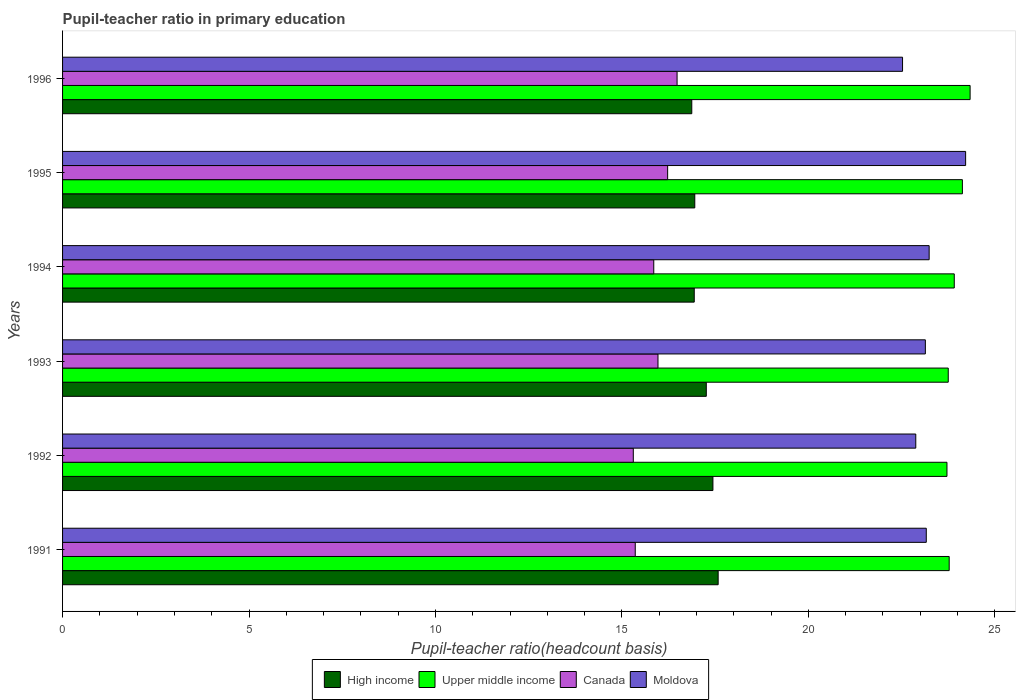How many different coloured bars are there?
Offer a terse response. 4. How many groups of bars are there?
Give a very brief answer. 6. Are the number of bars per tick equal to the number of legend labels?
Your answer should be very brief. Yes. How many bars are there on the 5th tick from the top?
Provide a short and direct response. 4. What is the label of the 1st group of bars from the top?
Your answer should be compact. 1996. In how many cases, is the number of bars for a given year not equal to the number of legend labels?
Your response must be concise. 0. What is the pupil-teacher ratio in primary education in High income in 1991?
Your answer should be very brief. 17.58. Across all years, what is the maximum pupil-teacher ratio in primary education in Moldova?
Your answer should be compact. 24.22. Across all years, what is the minimum pupil-teacher ratio in primary education in High income?
Your answer should be very brief. 16.87. What is the total pupil-teacher ratio in primary education in High income in the graph?
Offer a terse response. 103.05. What is the difference between the pupil-teacher ratio in primary education in Canada in 1995 and that in 1996?
Give a very brief answer. -0.25. What is the difference between the pupil-teacher ratio in primary education in Canada in 1992 and the pupil-teacher ratio in primary education in High income in 1996?
Keep it short and to the point. -1.57. What is the average pupil-teacher ratio in primary education in High income per year?
Offer a terse response. 17.17. In the year 1991, what is the difference between the pupil-teacher ratio in primary education in High income and pupil-teacher ratio in primary education in Canada?
Provide a short and direct response. 2.22. What is the ratio of the pupil-teacher ratio in primary education in High income in 1992 to that in 1994?
Offer a very short reply. 1.03. What is the difference between the highest and the second highest pupil-teacher ratio in primary education in Canada?
Offer a very short reply. 0.25. What is the difference between the highest and the lowest pupil-teacher ratio in primary education in Canada?
Ensure brevity in your answer.  1.17. In how many years, is the pupil-teacher ratio in primary education in High income greater than the average pupil-teacher ratio in primary education in High income taken over all years?
Make the answer very short. 3. What does the 3rd bar from the top in 1992 represents?
Ensure brevity in your answer.  Upper middle income. Is it the case that in every year, the sum of the pupil-teacher ratio in primary education in Upper middle income and pupil-teacher ratio in primary education in Moldova is greater than the pupil-teacher ratio in primary education in High income?
Provide a succinct answer. Yes. Does the graph contain any zero values?
Ensure brevity in your answer.  No. Does the graph contain grids?
Offer a terse response. No. Where does the legend appear in the graph?
Your answer should be very brief. Bottom center. How many legend labels are there?
Provide a succinct answer. 4. What is the title of the graph?
Offer a terse response. Pupil-teacher ratio in primary education. Does "Dominican Republic" appear as one of the legend labels in the graph?
Ensure brevity in your answer.  No. What is the label or title of the X-axis?
Offer a very short reply. Pupil-teacher ratio(headcount basis). What is the label or title of the Y-axis?
Your answer should be very brief. Years. What is the Pupil-teacher ratio(headcount basis) in High income in 1991?
Offer a very short reply. 17.58. What is the Pupil-teacher ratio(headcount basis) in Upper middle income in 1991?
Ensure brevity in your answer.  23.78. What is the Pupil-teacher ratio(headcount basis) in Canada in 1991?
Provide a succinct answer. 15.36. What is the Pupil-teacher ratio(headcount basis) in Moldova in 1991?
Offer a very short reply. 23.16. What is the Pupil-teacher ratio(headcount basis) of High income in 1992?
Ensure brevity in your answer.  17.44. What is the Pupil-teacher ratio(headcount basis) of Upper middle income in 1992?
Provide a short and direct response. 23.72. What is the Pupil-teacher ratio(headcount basis) in Canada in 1992?
Provide a short and direct response. 15.3. What is the Pupil-teacher ratio(headcount basis) in Moldova in 1992?
Offer a very short reply. 22.88. What is the Pupil-teacher ratio(headcount basis) of High income in 1993?
Your response must be concise. 17.26. What is the Pupil-teacher ratio(headcount basis) in Upper middle income in 1993?
Keep it short and to the point. 23.75. What is the Pupil-teacher ratio(headcount basis) in Canada in 1993?
Your answer should be compact. 15.97. What is the Pupil-teacher ratio(headcount basis) in Moldova in 1993?
Offer a very short reply. 23.14. What is the Pupil-teacher ratio(headcount basis) in High income in 1994?
Your answer should be very brief. 16.94. What is the Pupil-teacher ratio(headcount basis) in Upper middle income in 1994?
Provide a short and direct response. 23.91. What is the Pupil-teacher ratio(headcount basis) of Canada in 1994?
Ensure brevity in your answer.  15.85. What is the Pupil-teacher ratio(headcount basis) of Moldova in 1994?
Provide a short and direct response. 23.24. What is the Pupil-teacher ratio(headcount basis) of High income in 1995?
Offer a terse response. 16.95. What is the Pupil-teacher ratio(headcount basis) in Upper middle income in 1995?
Your response must be concise. 24.13. What is the Pupil-teacher ratio(headcount basis) of Canada in 1995?
Offer a very short reply. 16.23. What is the Pupil-teacher ratio(headcount basis) in Moldova in 1995?
Your response must be concise. 24.22. What is the Pupil-teacher ratio(headcount basis) in High income in 1996?
Provide a succinct answer. 16.87. What is the Pupil-teacher ratio(headcount basis) in Upper middle income in 1996?
Provide a succinct answer. 24.34. What is the Pupil-teacher ratio(headcount basis) of Canada in 1996?
Give a very brief answer. 16.48. What is the Pupil-teacher ratio(headcount basis) of Moldova in 1996?
Your answer should be very brief. 22.52. Across all years, what is the maximum Pupil-teacher ratio(headcount basis) of High income?
Provide a short and direct response. 17.58. Across all years, what is the maximum Pupil-teacher ratio(headcount basis) of Upper middle income?
Offer a terse response. 24.34. Across all years, what is the maximum Pupil-teacher ratio(headcount basis) of Canada?
Offer a terse response. 16.48. Across all years, what is the maximum Pupil-teacher ratio(headcount basis) in Moldova?
Give a very brief answer. 24.22. Across all years, what is the minimum Pupil-teacher ratio(headcount basis) of High income?
Your response must be concise. 16.87. Across all years, what is the minimum Pupil-teacher ratio(headcount basis) in Upper middle income?
Keep it short and to the point. 23.72. Across all years, what is the minimum Pupil-teacher ratio(headcount basis) of Canada?
Keep it short and to the point. 15.3. Across all years, what is the minimum Pupil-teacher ratio(headcount basis) in Moldova?
Make the answer very short. 22.52. What is the total Pupil-teacher ratio(headcount basis) in High income in the graph?
Your answer should be very brief. 103.05. What is the total Pupil-teacher ratio(headcount basis) of Upper middle income in the graph?
Make the answer very short. 143.62. What is the total Pupil-teacher ratio(headcount basis) in Canada in the graph?
Offer a terse response. 95.19. What is the total Pupil-teacher ratio(headcount basis) in Moldova in the graph?
Keep it short and to the point. 139.16. What is the difference between the Pupil-teacher ratio(headcount basis) of High income in 1991 and that in 1992?
Offer a terse response. 0.14. What is the difference between the Pupil-teacher ratio(headcount basis) in Upper middle income in 1991 and that in 1992?
Make the answer very short. 0.06. What is the difference between the Pupil-teacher ratio(headcount basis) of Canada in 1991 and that in 1992?
Offer a very short reply. 0.05. What is the difference between the Pupil-teacher ratio(headcount basis) in Moldova in 1991 and that in 1992?
Make the answer very short. 0.28. What is the difference between the Pupil-teacher ratio(headcount basis) of High income in 1991 and that in 1993?
Your response must be concise. 0.32. What is the difference between the Pupil-teacher ratio(headcount basis) of Upper middle income in 1991 and that in 1993?
Provide a short and direct response. 0.03. What is the difference between the Pupil-teacher ratio(headcount basis) in Canada in 1991 and that in 1993?
Offer a terse response. -0.61. What is the difference between the Pupil-teacher ratio(headcount basis) of Moldova in 1991 and that in 1993?
Your response must be concise. 0.02. What is the difference between the Pupil-teacher ratio(headcount basis) of High income in 1991 and that in 1994?
Your answer should be compact. 0.64. What is the difference between the Pupil-teacher ratio(headcount basis) of Upper middle income in 1991 and that in 1994?
Provide a succinct answer. -0.14. What is the difference between the Pupil-teacher ratio(headcount basis) of Canada in 1991 and that in 1994?
Give a very brief answer. -0.5. What is the difference between the Pupil-teacher ratio(headcount basis) of Moldova in 1991 and that in 1994?
Offer a terse response. -0.08. What is the difference between the Pupil-teacher ratio(headcount basis) of High income in 1991 and that in 1995?
Offer a very short reply. 0.63. What is the difference between the Pupil-teacher ratio(headcount basis) of Upper middle income in 1991 and that in 1995?
Ensure brevity in your answer.  -0.35. What is the difference between the Pupil-teacher ratio(headcount basis) in Canada in 1991 and that in 1995?
Provide a succinct answer. -0.87. What is the difference between the Pupil-teacher ratio(headcount basis) in Moldova in 1991 and that in 1995?
Offer a very short reply. -1.06. What is the difference between the Pupil-teacher ratio(headcount basis) in High income in 1991 and that in 1996?
Keep it short and to the point. 0.71. What is the difference between the Pupil-teacher ratio(headcount basis) of Upper middle income in 1991 and that in 1996?
Give a very brief answer. -0.56. What is the difference between the Pupil-teacher ratio(headcount basis) of Canada in 1991 and that in 1996?
Offer a very short reply. -1.12. What is the difference between the Pupil-teacher ratio(headcount basis) of Moldova in 1991 and that in 1996?
Give a very brief answer. 0.64. What is the difference between the Pupil-teacher ratio(headcount basis) of High income in 1992 and that in 1993?
Your answer should be compact. 0.18. What is the difference between the Pupil-teacher ratio(headcount basis) in Upper middle income in 1992 and that in 1993?
Provide a succinct answer. -0.03. What is the difference between the Pupil-teacher ratio(headcount basis) in Canada in 1992 and that in 1993?
Your answer should be compact. -0.66. What is the difference between the Pupil-teacher ratio(headcount basis) in Moldova in 1992 and that in 1993?
Your answer should be compact. -0.26. What is the difference between the Pupil-teacher ratio(headcount basis) of High income in 1992 and that in 1994?
Ensure brevity in your answer.  0.5. What is the difference between the Pupil-teacher ratio(headcount basis) of Upper middle income in 1992 and that in 1994?
Provide a short and direct response. -0.2. What is the difference between the Pupil-teacher ratio(headcount basis) of Canada in 1992 and that in 1994?
Ensure brevity in your answer.  -0.55. What is the difference between the Pupil-teacher ratio(headcount basis) of Moldova in 1992 and that in 1994?
Give a very brief answer. -0.36. What is the difference between the Pupil-teacher ratio(headcount basis) of High income in 1992 and that in 1995?
Provide a short and direct response. 0.49. What is the difference between the Pupil-teacher ratio(headcount basis) of Upper middle income in 1992 and that in 1995?
Offer a terse response. -0.41. What is the difference between the Pupil-teacher ratio(headcount basis) in Canada in 1992 and that in 1995?
Provide a short and direct response. -0.92. What is the difference between the Pupil-teacher ratio(headcount basis) of Moldova in 1992 and that in 1995?
Ensure brevity in your answer.  -1.34. What is the difference between the Pupil-teacher ratio(headcount basis) in High income in 1992 and that in 1996?
Your response must be concise. 0.57. What is the difference between the Pupil-teacher ratio(headcount basis) in Upper middle income in 1992 and that in 1996?
Provide a short and direct response. -0.62. What is the difference between the Pupil-teacher ratio(headcount basis) in Canada in 1992 and that in 1996?
Give a very brief answer. -1.17. What is the difference between the Pupil-teacher ratio(headcount basis) of Moldova in 1992 and that in 1996?
Your answer should be compact. 0.35. What is the difference between the Pupil-teacher ratio(headcount basis) of High income in 1993 and that in 1994?
Your answer should be very brief. 0.32. What is the difference between the Pupil-teacher ratio(headcount basis) in Upper middle income in 1993 and that in 1994?
Provide a succinct answer. -0.16. What is the difference between the Pupil-teacher ratio(headcount basis) in Canada in 1993 and that in 1994?
Provide a short and direct response. 0.11. What is the difference between the Pupil-teacher ratio(headcount basis) in Moldova in 1993 and that in 1994?
Your answer should be compact. -0.1. What is the difference between the Pupil-teacher ratio(headcount basis) of High income in 1993 and that in 1995?
Make the answer very short. 0.31. What is the difference between the Pupil-teacher ratio(headcount basis) in Upper middle income in 1993 and that in 1995?
Make the answer very short. -0.38. What is the difference between the Pupil-teacher ratio(headcount basis) in Canada in 1993 and that in 1995?
Keep it short and to the point. -0.26. What is the difference between the Pupil-teacher ratio(headcount basis) of Moldova in 1993 and that in 1995?
Provide a succinct answer. -1.08. What is the difference between the Pupil-teacher ratio(headcount basis) in High income in 1993 and that in 1996?
Offer a very short reply. 0.39. What is the difference between the Pupil-teacher ratio(headcount basis) of Upper middle income in 1993 and that in 1996?
Your answer should be very brief. -0.59. What is the difference between the Pupil-teacher ratio(headcount basis) of Canada in 1993 and that in 1996?
Provide a succinct answer. -0.51. What is the difference between the Pupil-teacher ratio(headcount basis) in Moldova in 1993 and that in 1996?
Provide a short and direct response. 0.61. What is the difference between the Pupil-teacher ratio(headcount basis) of High income in 1994 and that in 1995?
Keep it short and to the point. -0.01. What is the difference between the Pupil-teacher ratio(headcount basis) in Upper middle income in 1994 and that in 1995?
Provide a short and direct response. -0.22. What is the difference between the Pupil-teacher ratio(headcount basis) in Canada in 1994 and that in 1995?
Offer a very short reply. -0.37. What is the difference between the Pupil-teacher ratio(headcount basis) in Moldova in 1994 and that in 1995?
Give a very brief answer. -0.98. What is the difference between the Pupil-teacher ratio(headcount basis) in High income in 1994 and that in 1996?
Give a very brief answer. 0.07. What is the difference between the Pupil-teacher ratio(headcount basis) of Upper middle income in 1994 and that in 1996?
Provide a succinct answer. -0.42. What is the difference between the Pupil-teacher ratio(headcount basis) of Canada in 1994 and that in 1996?
Make the answer very short. -0.62. What is the difference between the Pupil-teacher ratio(headcount basis) of Moldova in 1994 and that in 1996?
Your response must be concise. 0.71. What is the difference between the Pupil-teacher ratio(headcount basis) in High income in 1995 and that in 1996?
Ensure brevity in your answer.  0.08. What is the difference between the Pupil-teacher ratio(headcount basis) in Upper middle income in 1995 and that in 1996?
Your answer should be very brief. -0.21. What is the difference between the Pupil-teacher ratio(headcount basis) in Canada in 1995 and that in 1996?
Offer a terse response. -0.25. What is the difference between the Pupil-teacher ratio(headcount basis) in Moldova in 1995 and that in 1996?
Make the answer very short. 1.69. What is the difference between the Pupil-teacher ratio(headcount basis) of High income in 1991 and the Pupil-teacher ratio(headcount basis) of Upper middle income in 1992?
Provide a short and direct response. -6.14. What is the difference between the Pupil-teacher ratio(headcount basis) of High income in 1991 and the Pupil-teacher ratio(headcount basis) of Canada in 1992?
Offer a very short reply. 2.28. What is the difference between the Pupil-teacher ratio(headcount basis) in High income in 1991 and the Pupil-teacher ratio(headcount basis) in Moldova in 1992?
Offer a very short reply. -5.3. What is the difference between the Pupil-teacher ratio(headcount basis) in Upper middle income in 1991 and the Pupil-teacher ratio(headcount basis) in Canada in 1992?
Give a very brief answer. 8.47. What is the difference between the Pupil-teacher ratio(headcount basis) of Upper middle income in 1991 and the Pupil-teacher ratio(headcount basis) of Moldova in 1992?
Keep it short and to the point. 0.9. What is the difference between the Pupil-teacher ratio(headcount basis) in Canada in 1991 and the Pupil-teacher ratio(headcount basis) in Moldova in 1992?
Your answer should be very brief. -7.52. What is the difference between the Pupil-teacher ratio(headcount basis) in High income in 1991 and the Pupil-teacher ratio(headcount basis) in Upper middle income in 1993?
Your response must be concise. -6.17. What is the difference between the Pupil-teacher ratio(headcount basis) in High income in 1991 and the Pupil-teacher ratio(headcount basis) in Canada in 1993?
Offer a terse response. 1.61. What is the difference between the Pupil-teacher ratio(headcount basis) in High income in 1991 and the Pupil-teacher ratio(headcount basis) in Moldova in 1993?
Offer a terse response. -5.56. What is the difference between the Pupil-teacher ratio(headcount basis) in Upper middle income in 1991 and the Pupil-teacher ratio(headcount basis) in Canada in 1993?
Your response must be concise. 7.81. What is the difference between the Pupil-teacher ratio(headcount basis) of Upper middle income in 1991 and the Pupil-teacher ratio(headcount basis) of Moldova in 1993?
Your response must be concise. 0.64. What is the difference between the Pupil-teacher ratio(headcount basis) of Canada in 1991 and the Pupil-teacher ratio(headcount basis) of Moldova in 1993?
Keep it short and to the point. -7.78. What is the difference between the Pupil-teacher ratio(headcount basis) of High income in 1991 and the Pupil-teacher ratio(headcount basis) of Upper middle income in 1994?
Provide a succinct answer. -6.33. What is the difference between the Pupil-teacher ratio(headcount basis) in High income in 1991 and the Pupil-teacher ratio(headcount basis) in Canada in 1994?
Give a very brief answer. 1.73. What is the difference between the Pupil-teacher ratio(headcount basis) of High income in 1991 and the Pupil-teacher ratio(headcount basis) of Moldova in 1994?
Keep it short and to the point. -5.66. What is the difference between the Pupil-teacher ratio(headcount basis) in Upper middle income in 1991 and the Pupil-teacher ratio(headcount basis) in Canada in 1994?
Offer a very short reply. 7.92. What is the difference between the Pupil-teacher ratio(headcount basis) of Upper middle income in 1991 and the Pupil-teacher ratio(headcount basis) of Moldova in 1994?
Make the answer very short. 0.54. What is the difference between the Pupil-teacher ratio(headcount basis) in Canada in 1991 and the Pupil-teacher ratio(headcount basis) in Moldova in 1994?
Provide a succinct answer. -7.88. What is the difference between the Pupil-teacher ratio(headcount basis) in High income in 1991 and the Pupil-teacher ratio(headcount basis) in Upper middle income in 1995?
Your response must be concise. -6.55. What is the difference between the Pupil-teacher ratio(headcount basis) of High income in 1991 and the Pupil-teacher ratio(headcount basis) of Canada in 1995?
Your answer should be compact. 1.35. What is the difference between the Pupil-teacher ratio(headcount basis) of High income in 1991 and the Pupil-teacher ratio(headcount basis) of Moldova in 1995?
Make the answer very short. -6.64. What is the difference between the Pupil-teacher ratio(headcount basis) of Upper middle income in 1991 and the Pupil-teacher ratio(headcount basis) of Canada in 1995?
Your response must be concise. 7.55. What is the difference between the Pupil-teacher ratio(headcount basis) of Upper middle income in 1991 and the Pupil-teacher ratio(headcount basis) of Moldova in 1995?
Your answer should be very brief. -0.44. What is the difference between the Pupil-teacher ratio(headcount basis) of Canada in 1991 and the Pupil-teacher ratio(headcount basis) of Moldova in 1995?
Provide a succinct answer. -8.86. What is the difference between the Pupil-teacher ratio(headcount basis) in High income in 1991 and the Pupil-teacher ratio(headcount basis) in Upper middle income in 1996?
Give a very brief answer. -6.76. What is the difference between the Pupil-teacher ratio(headcount basis) in High income in 1991 and the Pupil-teacher ratio(headcount basis) in Canada in 1996?
Offer a terse response. 1.1. What is the difference between the Pupil-teacher ratio(headcount basis) of High income in 1991 and the Pupil-teacher ratio(headcount basis) of Moldova in 1996?
Provide a succinct answer. -4.94. What is the difference between the Pupil-teacher ratio(headcount basis) in Upper middle income in 1991 and the Pupil-teacher ratio(headcount basis) in Canada in 1996?
Provide a short and direct response. 7.3. What is the difference between the Pupil-teacher ratio(headcount basis) in Upper middle income in 1991 and the Pupil-teacher ratio(headcount basis) in Moldova in 1996?
Your response must be concise. 1.25. What is the difference between the Pupil-teacher ratio(headcount basis) in Canada in 1991 and the Pupil-teacher ratio(headcount basis) in Moldova in 1996?
Provide a succinct answer. -7.17. What is the difference between the Pupil-teacher ratio(headcount basis) of High income in 1992 and the Pupil-teacher ratio(headcount basis) of Upper middle income in 1993?
Ensure brevity in your answer.  -6.31. What is the difference between the Pupil-teacher ratio(headcount basis) in High income in 1992 and the Pupil-teacher ratio(headcount basis) in Canada in 1993?
Provide a short and direct response. 1.47. What is the difference between the Pupil-teacher ratio(headcount basis) of High income in 1992 and the Pupil-teacher ratio(headcount basis) of Moldova in 1993?
Keep it short and to the point. -5.7. What is the difference between the Pupil-teacher ratio(headcount basis) of Upper middle income in 1992 and the Pupil-teacher ratio(headcount basis) of Canada in 1993?
Your answer should be very brief. 7.75. What is the difference between the Pupil-teacher ratio(headcount basis) in Upper middle income in 1992 and the Pupil-teacher ratio(headcount basis) in Moldova in 1993?
Ensure brevity in your answer.  0.58. What is the difference between the Pupil-teacher ratio(headcount basis) in Canada in 1992 and the Pupil-teacher ratio(headcount basis) in Moldova in 1993?
Ensure brevity in your answer.  -7.83. What is the difference between the Pupil-teacher ratio(headcount basis) of High income in 1992 and the Pupil-teacher ratio(headcount basis) of Upper middle income in 1994?
Your response must be concise. -6.47. What is the difference between the Pupil-teacher ratio(headcount basis) in High income in 1992 and the Pupil-teacher ratio(headcount basis) in Canada in 1994?
Make the answer very short. 1.59. What is the difference between the Pupil-teacher ratio(headcount basis) of High income in 1992 and the Pupil-teacher ratio(headcount basis) of Moldova in 1994?
Offer a very short reply. -5.8. What is the difference between the Pupil-teacher ratio(headcount basis) of Upper middle income in 1992 and the Pupil-teacher ratio(headcount basis) of Canada in 1994?
Provide a short and direct response. 7.86. What is the difference between the Pupil-teacher ratio(headcount basis) in Upper middle income in 1992 and the Pupil-teacher ratio(headcount basis) in Moldova in 1994?
Provide a short and direct response. 0.48. What is the difference between the Pupil-teacher ratio(headcount basis) in Canada in 1992 and the Pupil-teacher ratio(headcount basis) in Moldova in 1994?
Your response must be concise. -7.93. What is the difference between the Pupil-teacher ratio(headcount basis) of High income in 1992 and the Pupil-teacher ratio(headcount basis) of Upper middle income in 1995?
Provide a short and direct response. -6.69. What is the difference between the Pupil-teacher ratio(headcount basis) in High income in 1992 and the Pupil-teacher ratio(headcount basis) in Canada in 1995?
Provide a succinct answer. 1.21. What is the difference between the Pupil-teacher ratio(headcount basis) in High income in 1992 and the Pupil-teacher ratio(headcount basis) in Moldova in 1995?
Your answer should be very brief. -6.78. What is the difference between the Pupil-teacher ratio(headcount basis) in Upper middle income in 1992 and the Pupil-teacher ratio(headcount basis) in Canada in 1995?
Provide a short and direct response. 7.49. What is the difference between the Pupil-teacher ratio(headcount basis) in Upper middle income in 1992 and the Pupil-teacher ratio(headcount basis) in Moldova in 1995?
Offer a terse response. -0.5. What is the difference between the Pupil-teacher ratio(headcount basis) of Canada in 1992 and the Pupil-teacher ratio(headcount basis) of Moldova in 1995?
Your answer should be very brief. -8.91. What is the difference between the Pupil-teacher ratio(headcount basis) in High income in 1992 and the Pupil-teacher ratio(headcount basis) in Upper middle income in 1996?
Your answer should be compact. -6.9. What is the difference between the Pupil-teacher ratio(headcount basis) in High income in 1992 and the Pupil-teacher ratio(headcount basis) in Canada in 1996?
Your answer should be very brief. 0.96. What is the difference between the Pupil-teacher ratio(headcount basis) of High income in 1992 and the Pupil-teacher ratio(headcount basis) of Moldova in 1996?
Offer a terse response. -5.08. What is the difference between the Pupil-teacher ratio(headcount basis) of Upper middle income in 1992 and the Pupil-teacher ratio(headcount basis) of Canada in 1996?
Provide a succinct answer. 7.24. What is the difference between the Pupil-teacher ratio(headcount basis) of Upper middle income in 1992 and the Pupil-teacher ratio(headcount basis) of Moldova in 1996?
Provide a succinct answer. 1.19. What is the difference between the Pupil-teacher ratio(headcount basis) in Canada in 1992 and the Pupil-teacher ratio(headcount basis) in Moldova in 1996?
Offer a very short reply. -7.22. What is the difference between the Pupil-teacher ratio(headcount basis) of High income in 1993 and the Pupil-teacher ratio(headcount basis) of Upper middle income in 1994?
Offer a very short reply. -6.65. What is the difference between the Pupil-teacher ratio(headcount basis) in High income in 1993 and the Pupil-teacher ratio(headcount basis) in Canada in 1994?
Offer a terse response. 1.41. What is the difference between the Pupil-teacher ratio(headcount basis) in High income in 1993 and the Pupil-teacher ratio(headcount basis) in Moldova in 1994?
Offer a very short reply. -5.98. What is the difference between the Pupil-teacher ratio(headcount basis) of Upper middle income in 1993 and the Pupil-teacher ratio(headcount basis) of Canada in 1994?
Keep it short and to the point. 7.9. What is the difference between the Pupil-teacher ratio(headcount basis) of Upper middle income in 1993 and the Pupil-teacher ratio(headcount basis) of Moldova in 1994?
Keep it short and to the point. 0.51. What is the difference between the Pupil-teacher ratio(headcount basis) in Canada in 1993 and the Pupil-teacher ratio(headcount basis) in Moldova in 1994?
Ensure brevity in your answer.  -7.27. What is the difference between the Pupil-teacher ratio(headcount basis) of High income in 1993 and the Pupil-teacher ratio(headcount basis) of Upper middle income in 1995?
Provide a succinct answer. -6.87. What is the difference between the Pupil-teacher ratio(headcount basis) of High income in 1993 and the Pupil-teacher ratio(headcount basis) of Canada in 1995?
Your answer should be very brief. 1.04. What is the difference between the Pupil-teacher ratio(headcount basis) in High income in 1993 and the Pupil-teacher ratio(headcount basis) in Moldova in 1995?
Ensure brevity in your answer.  -6.95. What is the difference between the Pupil-teacher ratio(headcount basis) in Upper middle income in 1993 and the Pupil-teacher ratio(headcount basis) in Canada in 1995?
Offer a terse response. 7.53. What is the difference between the Pupil-teacher ratio(headcount basis) of Upper middle income in 1993 and the Pupil-teacher ratio(headcount basis) of Moldova in 1995?
Make the answer very short. -0.47. What is the difference between the Pupil-teacher ratio(headcount basis) in Canada in 1993 and the Pupil-teacher ratio(headcount basis) in Moldova in 1995?
Make the answer very short. -8.25. What is the difference between the Pupil-teacher ratio(headcount basis) in High income in 1993 and the Pupil-teacher ratio(headcount basis) in Upper middle income in 1996?
Ensure brevity in your answer.  -7.07. What is the difference between the Pupil-teacher ratio(headcount basis) of High income in 1993 and the Pupil-teacher ratio(headcount basis) of Canada in 1996?
Provide a succinct answer. 0.78. What is the difference between the Pupil-teacher ratio(headcount basis) of High income in 1993 and the Pupil-teacher ratio(headcount basis) of Moldova in 1996?
Ensure brevity in your answer.  -5.26. What is the difference between the Pupil-teacher ratio(headcount basis) of Upper middle income in 1993 and the Pupil-teacher ratio(headcount basis) of Canada in 1996?
Offer a very short reply. 7.27. What is the difference between the Pupil-teacher ratio(headcount basis) of Upper middle income in 1993 and the Pupil-teacher ratio(headcount basis) of Moldova in 1996?
Give a very brief answer. 1.23. What is the difference between the Pupil-teacher ratio(headcount basis) of Canada in 1993 and the Pupil-teacher ratio(headcount basis) of Moldova in 1996?
Keep it short and to the point. -6.56. What is the difference between the Pupil-teacher ratio(headcount basis) of High income in 1994 and the Pupil-teacher ratio(headcount basis) of Upper middle income in 1995?
Your response must be concise. -7.19. What is the difference between the Pupil-teacher ratio(headcount basis) of High income in 1994 and the Pupil-teacher ratio(headcount basis) of Canada in 1995?
Your response must be concise. 0.71. What is the difference between the Pupil-teacher ratio(headcount basis) in High income in 1994 and the Pupil-teacher ratio(headcount basis) in Moldova in 1995?
Provide a succinct answer. -7.28. What is the difference between the Pupil-teacher ratio(headcount basis) in Upper middle income in 1994 and the Pupil-teacher ratio(headcount basis) in Canada in 1995?
Make the answer very short. 7.69. What is the difference between the Pupil-teacher ratio(headcount basis) of Upper middle income in 1994 and the Pupil-teacher ratio(headcount basis) of Moldova in 1995?
Provide a succinct answer. -0.3. What is the difference between the Pupil-teacher ratio(headcount basis) of Canada in 1994 and the Pupil-teacher ratio(headcount basis) of Moldova in 1995?
Your response must be concise. -8.36. What is the difference between the Pupil-teacher ratio(headcount basis) in High income in 1994 and the Pupil-teacher ratio(headcount basis) in Upper middle income in 1996?
Ensure brevity in your answer.  -7.4. What is the difference between the Pupil-teacher ratio(headcount basis) in High income in 1994 and the Pupil-teacher ratio(headcount basis) in Canada in 1996?
Offer a very short reply. 0.46. What is the difference between the Pupil-teacher ratio(headcount basis) of High income in 1994 and the Pupil-teacher ratio(headcount basis) of Moldova in 1996?
Your answer should be compact. -5.59. What is the difference between the Pupil-teacher ratio(headcount basis) of Upper middle income in 1994 and the Pupil-teacher ratio(headcount basis) of Canada in 1996?
Keep it short and to the point. 7.43. What is the difference between the Pupil-teacher ratio(headcount basis) in Upper middle income in 1994 and the Pupil-teacher ratio(headcount basis) in Moldova in 1996?
Your response must be concise. 1.39. What is the difference between the Pupil-teacher ratio(headcount basis) of Canada in 1994 and the Pupil-teacher ratio(headcount basis) of Moldova in 1996?
Your answer should be compact. -6.67. What is the difference between the Pupil-teacher ratio(headcount basis) in High income in 1995 and the Pupil-teacher ratio(headcount basis) in Upper middle income in 1996?
Your answer should be very brief. -7.38. What is the difference between the Pupil-teacher ratio(headcount basis) of High income in 1995 and the Pupil-teacher ratio(headcount basis) of Canada in 1996?
Offer a very short reply. 0.47. What is the difference between the Pupil-teacher ratio(headcount basis) of High income in 1995 and the Pupil-teacher ratio(headcount basis) of Moldova in 1996?
Your answer should be compact. -5.57. What is the difference between the Pupil-teacher ratio(headcount basis) of Upper middle income in 1995 and the Pupil-teacher ratio(headcount basis) of Canada in 1996?
Keep it short and to the point. 7.65. What is the difference between the Pupil-teacher ratio(headcount basis) of Upper middle income in 1995 and the Pupil-teacher ratio(headcount basis) of Moldova in 1996?
Make the answer very short. 1.6. What is the difference between the Pupil-teacher ratio(headcount basis) in Canada in 1995 and the Pupil-teacher ratio(headcount basis) in Moldova in 1996?
Your answer should be compact. -6.3. What is the average Pupil-teacher ratio(headcount basis) in High income per year?
Your answer should be compact. 17.17. What is the average Pupil-teacher ratio(headcount basis) in Upper middle income per year?
Your answer should be compact. 23.94. What is the average Pupil-teacher ratio(headcount basis) in Canada per year?
Provide a succinct answer. 15.86. What is the average Pupil-teacher ratio(headcount basis) of Moldova per year?
Offer a very short reply. 23.19. In the year 1991, what is the difference between the Pupil-teacher ratio(headcount basis) of High income and Pupil-teacher ratio(headcount basis) of Upper middle income?
Your response must be concise. -6.2. In the year 1991, what is the difference between the Pupil-teacher ratio(headcount basis) in High income and Pupil-teacher ratio(headcount basis) in Canada?
Offer a terse response. 2.22. In the year 1991, what is the difference between the Pupil-teacher ratio(headcount basis) in High income and Pupil-teacher ratio(headcount basis) in Moldova?
Give a very brief answer. -5.58. In the year 1991, what is the difference between the Pupil-teacher ratio(headcount basis) of Upper middle income and Pupil-teacher ratio(headcount basis) of Canada?
Give a very brief answer. 8.42. In the year 1991, what is the difference between the Pupil-teacher ratio(headcount basis) in Upper middle income and Pupil-teacher ratio(headcount basis) in Moldova?
Ensure brevity in your answer.  0.61. In the year 1991, what is the difference between the Pupil-teacher ratio(headcount basis) in Canada and Pupil-teacher ratio(headcount basis) in Moldova?
Your answer should be very brief. -7.8. In the year 1992, what is the difference between the Pupil-teacher ratio(headcount basis) of High income and Pupil-teacher ratio(headcount basis) of Upper middle income?
Make the answer very short. -6.28. In the year 1992, what is the difference between the Pupil-teacher ratio(headcount basis) in High income and Pupil-teacher ratio(headcount basis) in Canada?
Make the answer very short. 2.14. In the year 1992, what is the difference between the Pupil-teacher ratio(headcount basis) in High income and Pupil-teacher ratio(headcount basis) in Moldova?
Give a very brief answer. -5.44. In the year 1992, what is the difference between the Pupil-teacher ratio(headcount basis) of Upper middle income and Pupil-teacher ratio(headcount basis) of Canada?
Keep it short and to the point. 8.41. In the year 1992, what is the difference between the Pupil-teacher ratio(headcount basis) in Upper middle income and Pupil-teacher ratio(headcount basis) in Moldova?
Provide a short and direct response. 0.84. In the year 1992, what is the difference between the Pupil-teacher ratio(headcount basis) in Canada and Pupil-teacher ratio(headcount basis) in Moldova?
Make the answer very short. -7.58. In the year 1993, what is the difference between the Pupil-teacher ratio(headcount basis) in High income and Pupil-teacher ratio(headcount basis) in Upper middle income?
Give a very brief answer. -6.49. In the year 1993, what is the difference between the Pupil-teacher ratio(headcount basis) in High income and Pupil-teacher ratio(headcount basis) in Canada?
Give a very brief answer. 1.3. In the year 1993, what is the difference between the Pupil-teacher ratio(headcount basis) in High income and Pupil-teacher ratio(headcount basis) in Moldova?
Keep it short and to the point. -5.87. In the year 1993, what is the difference between the Pupil-teacher ratio(headcount basis) in Upper middle income and Pupil-teacher ratio(headcount basis) in Canada?
Give a very brief answer. 7.78. In the year 1993, what is the difference between the Pupil-teacher ratio(headcount basis) in Upper middle income and Pupil-teacher ratio(headcount basis) in Moldova?
Give a very brief answer. 0.61. In the year 1993, what is the difference between the Pupil-teacher ratio(headcount basis) of Canada and Pupil-teacher ratio(headcount basis) of Moldova?
Make the answer very short. -7.17. In the year 1994, what is the difference between the Pupil-teacher ratio(headcount basis) of High income and Pupil-teacher ratio(headcount basis) of Upper middle income?
Keep it short and to the point. -6.97. In the year 1994, what is the difference between the Pupil-teacher ratio(headcount basis) in High income and Pupil-teacher ratio(headcount basis) in Canada?
Keep it short and to the point. 1.09. In the year 1994, what is the difference between the Pupil-teacher ratio(headcount basis) in High income and Pupil-teacher ratio(headcount basis) in Moldova?
Offer a terse response. -6.3. In the year 1994, what is the difference between the Pupil-teacher ratio(headcount basis) in Upper middle income and Pupil-teacher ratio(headcount basis) in Canada?
Make the answer very short. 8.06. In the year 1994, what is the difference between the Pupil-teacher ratio(headcount basis) of Upper middle income and Pupil-teacher ratio(headcount basis) of Moldova?
Offer a very short reply. 0.67. In the year 1994, what is the difference between the Pupil-teacher ratio(headcount basis) of Canada and Pupil-teacher ratio(headcount basis) of Moldova?
Provide a succinct answer. -7.38. In the year 1995, what is the difference between the Pupil-teacher ratio(headcount basis) of High income and Pupil-teacher ratio(headcount basis) of Upper middle income?
Offer a terse response. -7.18. In the year 1995, what is the difference between the Pupil-teacher ratio(headcount basis) in High income and Pupil-teacher ratio(headcount basis) in Canada?
Offer a very short reply. 0.73. In the year 1995, what is the difference between the Pupil-teacher ratio(headcount basis) in High income and Pupil-teacher ratio(headcount basis) in Moldova?
Provide a short and direct response. -7.26. In the year 1995, what is the difference between the Pupil-teacher ratio(headcount basis) of Upper middle income and Pupil-teacher ratio(headcount basis) of Canada?
Offer a very short reply. 7.9. In the year 1995, what is the difference between the Pupil-teacher ratio(headcount basis) of Upper middle income and Pupil-teacher ratio(headcount basis) of Moldova?
Your response must be concise. -0.09. In the year 1995, what is the difference between the Pupil-teacher ratio(headcount basis) of Canada and Pupil-teacher ratio(headcount basis) of Moldova?
Make the answer very short. -7.99. In the year 1996, what is the difference between the Pupil-teacher ratio(headcount basis) of High income and Pupil-teacher ratio(headcount basis) of Upper middle income?
Keep it short and to the point. -7.46. In the year 1996, what is the difference between the Pupil-teacher ratio(headcount basis) in High income and Pupil-teacher ratio(headcount basis) in Canada?
Your answer should be compact. 0.39. In the year 1996, what is the difference between the Pupil-teacher ratio(headcount basis) of High income and Pupil-teacher ratio(headcount basis) of Moldova?
Make the answer very short. -5.65. In the year 1996, what is the difference between the Pupil-teacher ratio(headcount basis) of Upper middle income and Pupil-teacher ratio(headcount basis) of Canada?
Keep it short and to the point. 7.86. In the year 1996, what is the difference between the Pupil-teacher ratio(headcount basis) in Upper middle income and Pupil-teacher ratio(headcount basis) in Moldova?
Keep it short and to the point. 1.81. In the year 1996, what is the difference between the Pupil-teacher ratio(headcount basis) of Canada and Pupil-teacher ratio(headcount basis) of Moldova?
Your answer should be very brief. -6.05. What is the ratio of the Pupil-teacher ratio(headcount basis) in High income in 1991 to that in 1992?
Offer a very short reply. 1.01. What is the ratio of the Pupil-teacher ratio(headcount basis) in Moldova in 1991 to that in 1992?
Provide a succinct answer. 1.01. What is the ratio of the Pupil-teacher ratio(headcount basis) of High income in 1991 to that in 1993?
Keep it short and to the point. 1.02. What is the ratio of the Pupil-teacher ratio(headcount basis) of Canada in 1991 to that in 1993?
Provide a short and direct response. 0.96. What is the ratio of the Pupil-teacher ratio(headcount basis) in High income in 1991 to that in 1994?
Offer a terse response. 1.04. What is the ratio of the Pupil-teacher ratio(headcount basis) in Canada in 1991 to that in 1994?
Give a very brief answer. 0.97. What is the ratio of the Pupil-teacher ratio(headcount basis) of Canada in 1991 to that in 1995?
Offer a terse response. 0.95. What is the ratio of the Pupil-teacher ratio(headcount basis) of Moldova in 1991 to that in 1995?
Offer a terse response. 0.96. What is the ratio of the Pupil-teacher ratio(headcount basis) of High income in 1991 to that in 1996?
Offer a very short reply. 1.04. What is the ratio of the Pupil-teacher ratio(headcount basis) in Upper middle income in 1991 to that in 1996?
Keep it short and to the point. 0.98. What is the ratio of the Pupil-teacher ratio(headcount basis) in Canada in 1991 to that in 1996?
Offer a terse response. 0.93. What is the ratio of the Pupil-teacher ratio(headcount basis) in Moldova in 1991 to that in 1996?
Offer a very short reply. 1.03. What is the ratio of the Pupil-teacher ratio(headcount basis) in High income in 1992 to that in 1993?
Your answer should be very brief. 1.01. What is the ratio of the Pupil-teacher ratio(headcount basis) of Canada in 1992 to that in 1993?
Ensure brevity in your answer.  0.96. What is the ratio of the Pupil-teacher ratio(headcount basis) in Moldova in 1992 to that in 1993?
Offer a very short reply. 0.99. What is the ratio of the Pupil-teacher ratio(headcount basis) of High income in 1992 to that in 1994?
Offer a terse response. 1.03. What is the ratio of the Pupil-teacher ratio(headcount basis) in Canada in 1992 to that in 1994?
Provide a short and direct response. 0.97. What is the ratio of the Pupil-teacher ratio(headcount basis) of Moldova in 1992 to that in 1994?
Offer a very short reply. 0.98. What is the ratio of the Pupil-teacher ratio(headcount basis) in High income in 1992 to that in 1995?
Your answer should be compact. 1.03. What is the ratio of the Pupil-teacher ratio(headcount basis) in Upper middle income in 1992 to that in 1995?
Offer a very short reply. 0.98. What is the ratio of the Pupil-teacher ratio(headcount basis) of Canada in 1992 to that in 1995?
Offer a very short reply. 0.94. What is the ratio of the Pupil-teacher ratio(headcount basis) in Moldova in 1992 to that in 1995?
Give a very brief answer. 0.94. What is the ratio of the Pupil-teacher ratio(headcount basis) of High income in 1992 to that in 1996?
Ensure brevity in your answer.  1.03. What is the ratio of the Pupil-teacher ratio(headcount basis) of Upper middle income in 1992 to that in 1996?
Offer a very short reply. 0.97. What is the ratio of the Pupil-teacher ratio(headcount basis) in Canada in 1992 to that in 1996?
Offer a terse response. 0.93. What is the ratio of the Pupil-teacher ratio(headcount basis) of Moldova in 1992 to that in 1996?
Make the answer very short. 1.02. What is the ratio of the Pupil-teacher ratio(headcount basis) in High income in 1993 to that in 1994?
Provide a short and direct response. 1.02. What is the ratio of the Pupil-teacher ratio(headcount basis) in Canada in 1993 to that in 1994?
Ensure brevity in your answer.  1.01. What is the ratio of the Pupil-teacher ratio(headcount basis) in High income in 1993 to that in 1995?
Offer a very short reply. 1.02. What is the ratio of the Pupil-teacher ratio(headcount basis) in Upper middle income in 1993 to that in 1995?
Provide a short and direct response. 0.98. What is the ratio of the Pupil-teacher ratio(headcount basis) in Moldova in 1993 to that in 1995?
Offer a terse response. 0.96. What is the ratio of the Pupil-teacher ratio(headcount basis) in High income in 1993 to that in 1996?
Provide a short and direct response. 1.02. What is the ratio of the Pupil-teacher ratio(headcount basis) in Upper middle income in 1993 to that in 1996?
Give a very brief answer. 0.98. What is the ratio of the Pupil-teacher ratio(headcount basis) of Canada in 1993 to that in 1996?
Your answer should be very brief. 0.97. What is the ratio of the Pupil-teacher ratio(headcount basis) of Moldova in 1993 to that in 1996?
Make the answer very short. 1.03. What is the ratio of the Pupil-teacher ratio(headcount basis) in Canada in 1994 to that in 1995?
Keep it short and to the point. 0.98. What is the ratio of the Pupil-teacher ratio(headcount basis) in Moldova in 1994 to that in 1995?
Make the answer very short. 0.96. What is the ratio of the Pupil-teacher ratio(headcount basis) of High income in 1994 to that in 1996?
Your answer should be compact. 1. What is the ratio of the Pupil-teacher ratio(headcount basis) in Upper middle income in 1994 to that in 1996?
Offer a terse response. 0.98. What is the ratio of the Pupil-teacher ratio(headcount basis) in Canada in 1994 to that in 1996?
Your response must be concise. 0.96. What is the ratio of the Pupil-teacher ratio(headcount basis) of Moldova in 1994 to that in 1996?
Make the answer very short. 1.03. What is the ratio of the Pupil-teacher ratio(headcount basis) of High income in 1995 to that in 1996?
Your answer should be very brief. 1. What is the ratio of the Pupil-teacher ratio(headcount basis) in Canada in 1995 to that in 1996?
Offer a terse response. 0.98. What is the ratio of the Pupil-teacher ratio(headcount basis) in Moldova in 1995 to that in 1996?
Keep it short and to the point. 1.08. What is the difference between the highest and the second highest Pupil-teacher ratio(headcount basis) of High income?
Ensure brevity in your answer.  0.14. What is the difference between the highest and the second highest Pupil-teacher ratio(headcount basis) of Upper middle income?
Give a very brief answer. 0.21. What is the difference between the highest and the second highest Pupil-teacher ratio(headcount basis) in Canada?
Make the answer very short. 0.25. What is the difference between the highest and the second highest Pupil-teacher ratio(headcount basis) of Moldova?
Your response must be concise. 0.98. What is the difference between the highest and the lowest Pupil-teacher ratio(headcount basis) of High income?
Provide a short and direct response. 0.71. What is the difference between the highest and the lowest Pupil-teacher ratio(headcount basis) of Upper middle income?
Offer a terse response. 0.62. What is the difference between the highest and the lowest Pupil-teacher ratio(headcount basis) in Canada?
Offer a very short reply. 1.17. What is the difference between the highest and the lowest Pupil-teacher ratio(headcount basis) in Moldova?
Make the answer very short. 1.69. 